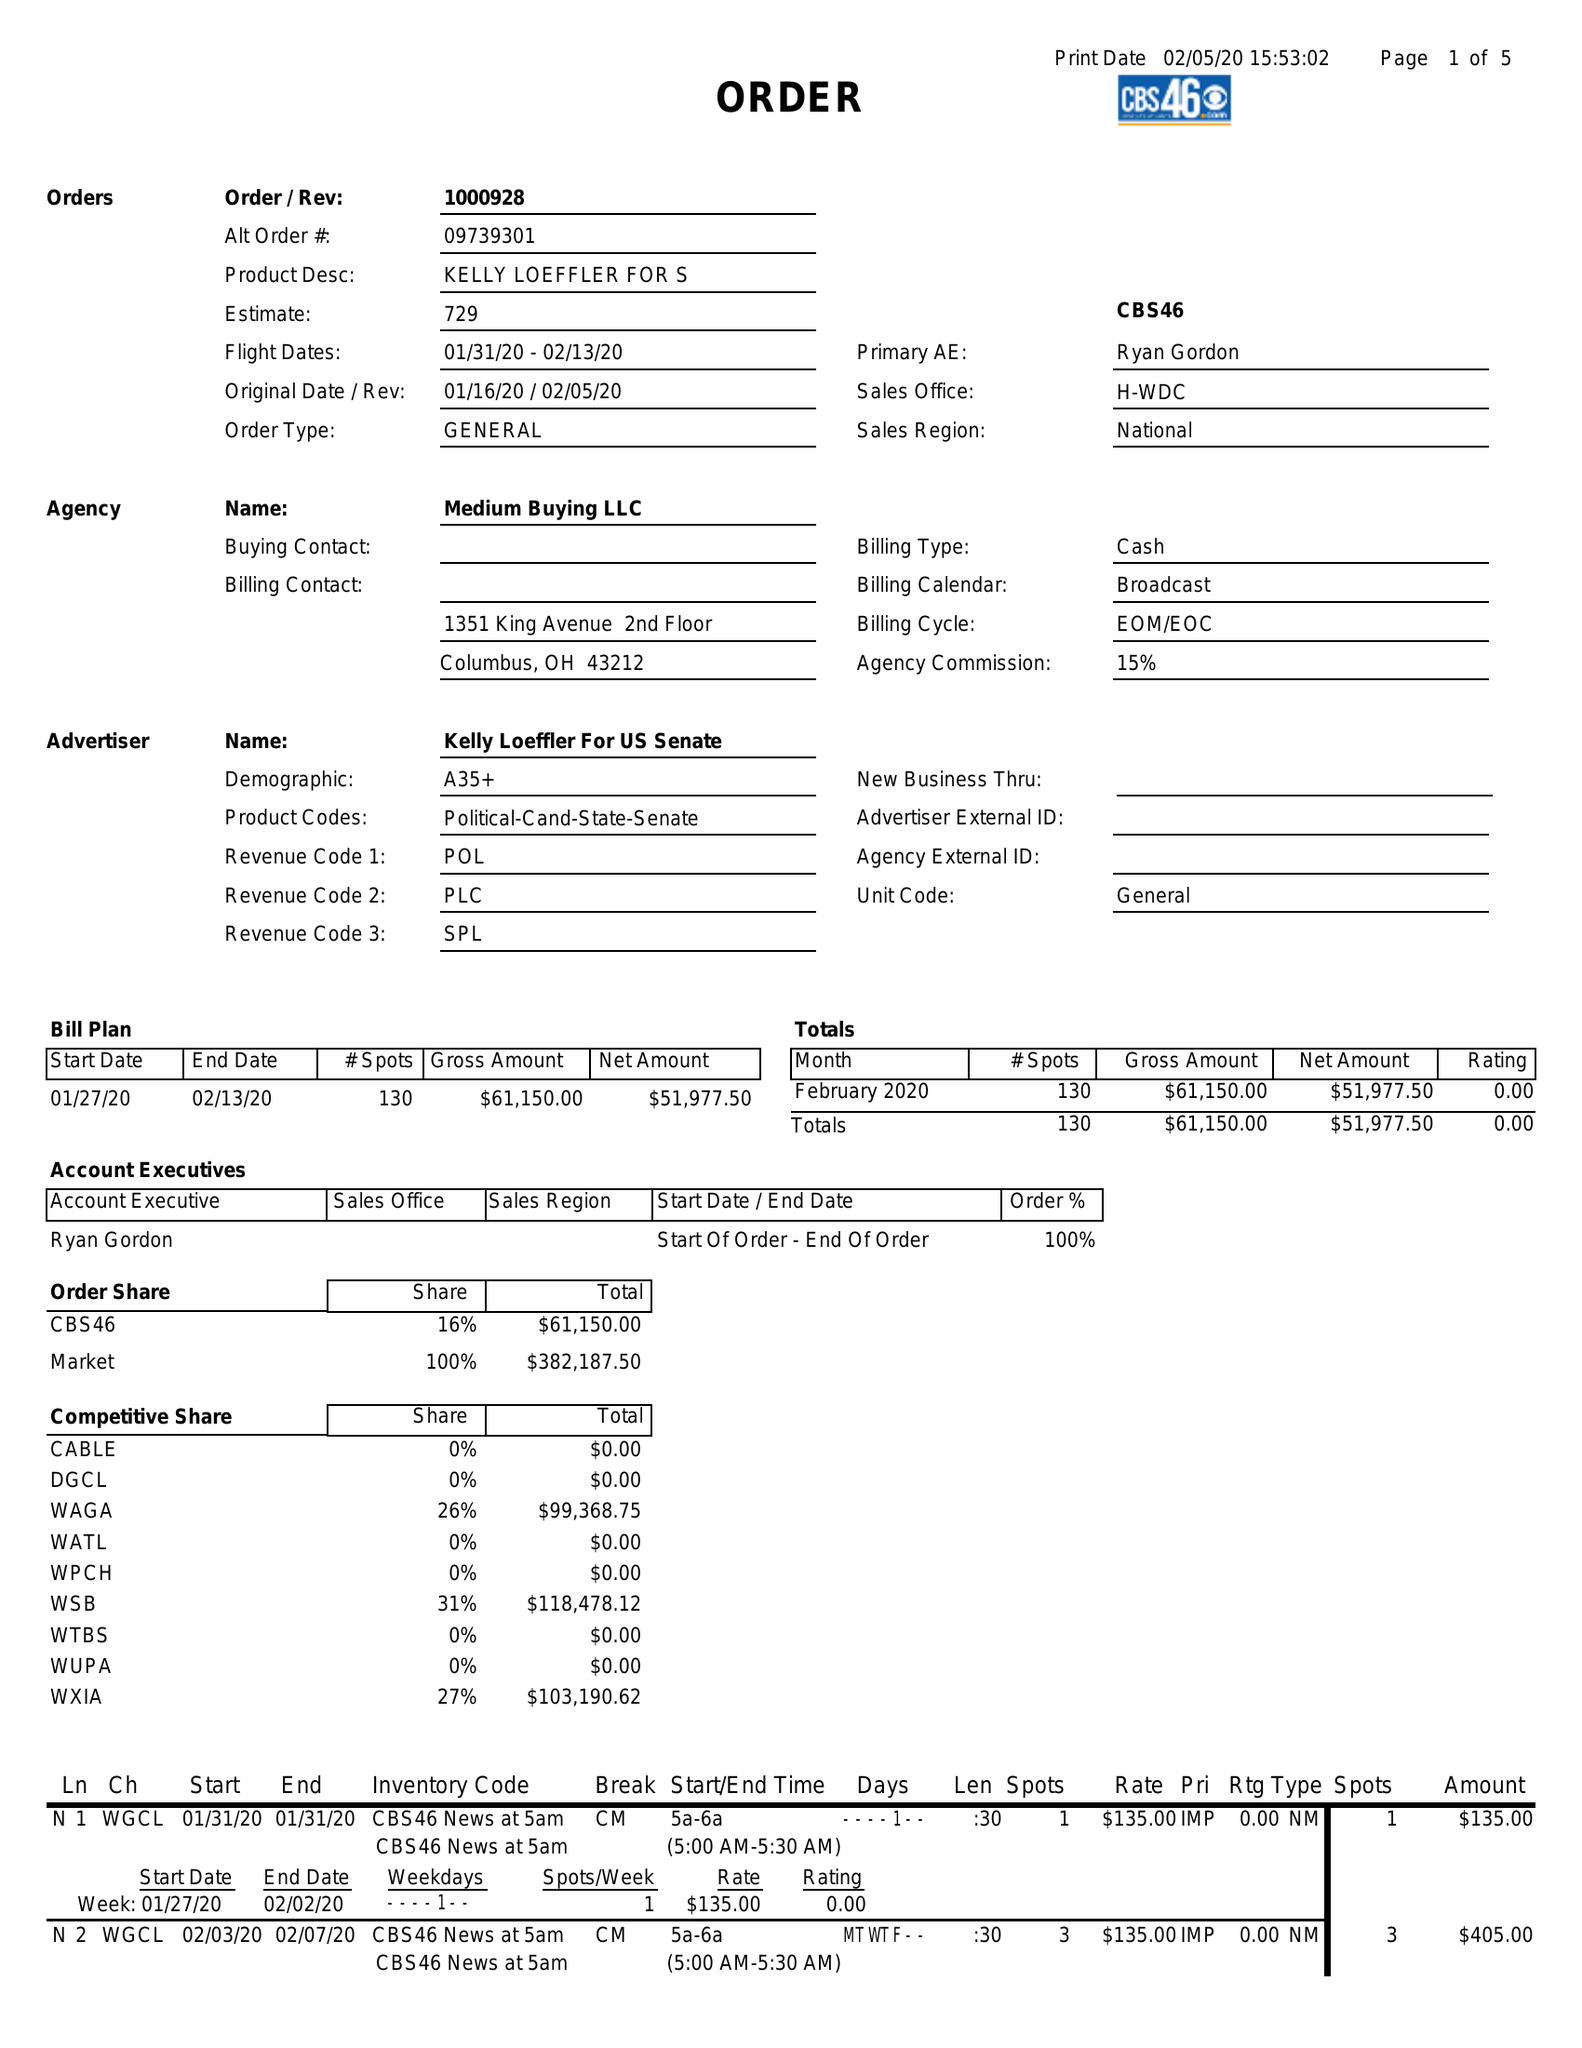What is the value for the contract_num?
Answer the question using a single word or phrase. 1000928 